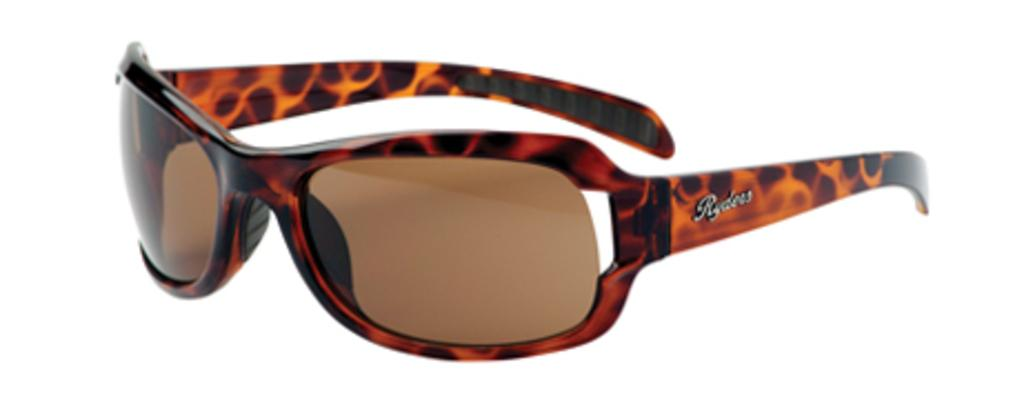What objects are present in the image? There are shades in the picture. What feature can be seen on the shades? The shades have a logo on them. What is the color of the background in the image? The background of the image is white in color. What type of trains can be seen passing through the territory in the image? There are no trains or territory present in the image; it only features shades with a logo and a white background. 